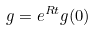Convert formula to latex. <formula><loc_0><loc_0><loc_500><loc_500>g = e ^ { R t } g ( 0 )</formula> 